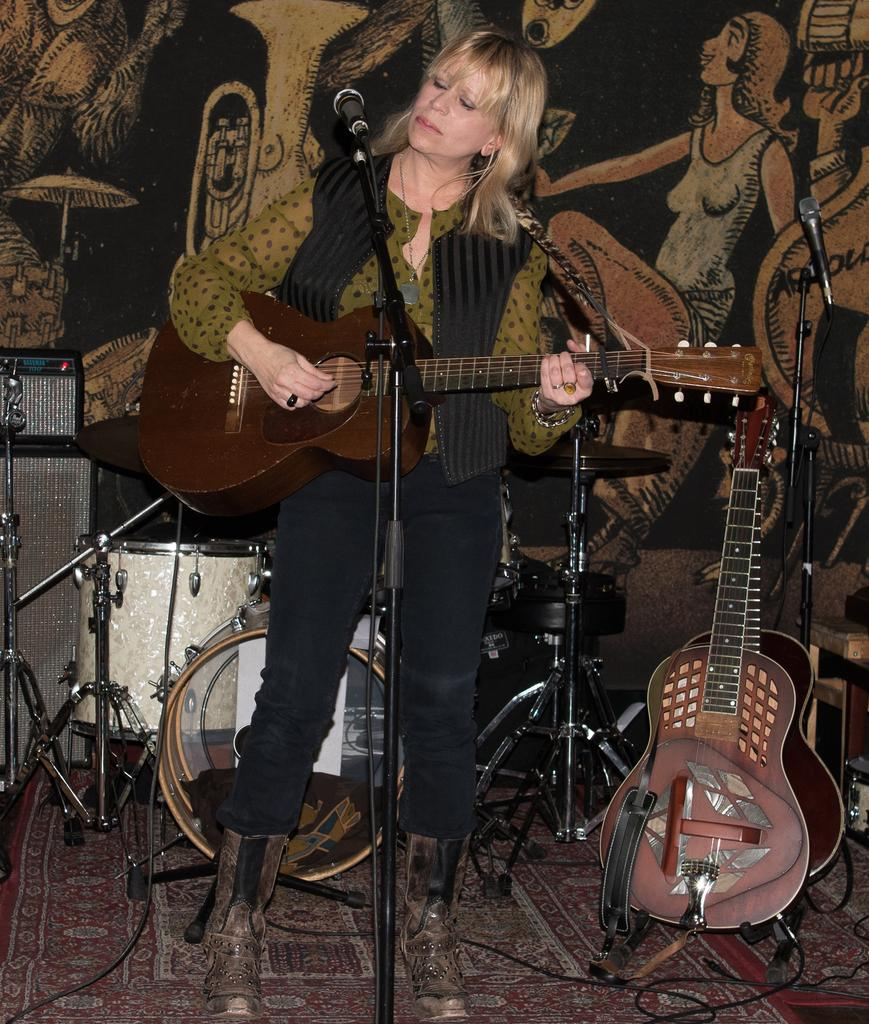Who is the main subject in the image? There is a woman in the image. What is the woman doing in the image? The woman is playing a guitar. What type of lawyer is advising the woman in the image? There is no lawyer present in the image, as the woman is playing a guitar. How comfortable is the chair the woman is sitting on in the image? The image does not provide information about the chair's comfort, as it only shows the woman playing a guitar. 